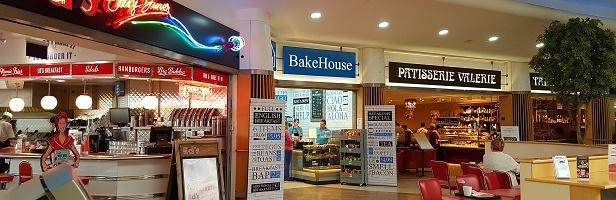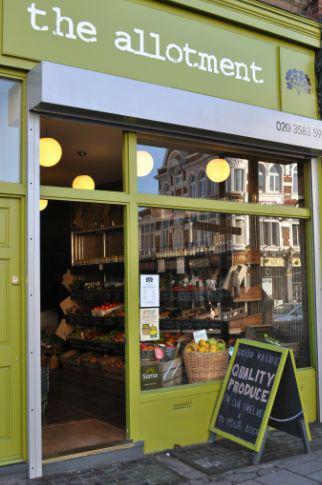The first image is the image on the left, the second image is the image on the right. Assess this claim about the two images: "Both images show bakeries with the same name.". Correct or not? Answer yes or no. No. The first image is the image on the left, the second image is the image on the right. Given the left and right images, does the statement "People are standing in front of a restaurant." hold true? Answer yes or no. No. 